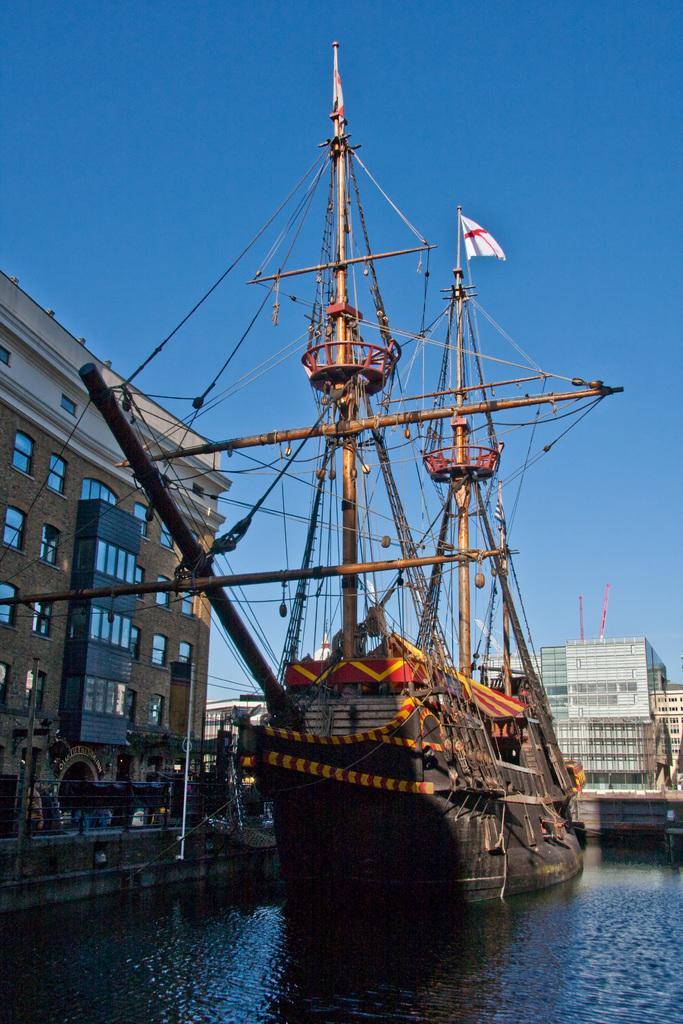Please provide a concise description of this image. In this image there is a ship on the river. In the background there are buildings and the sky. 